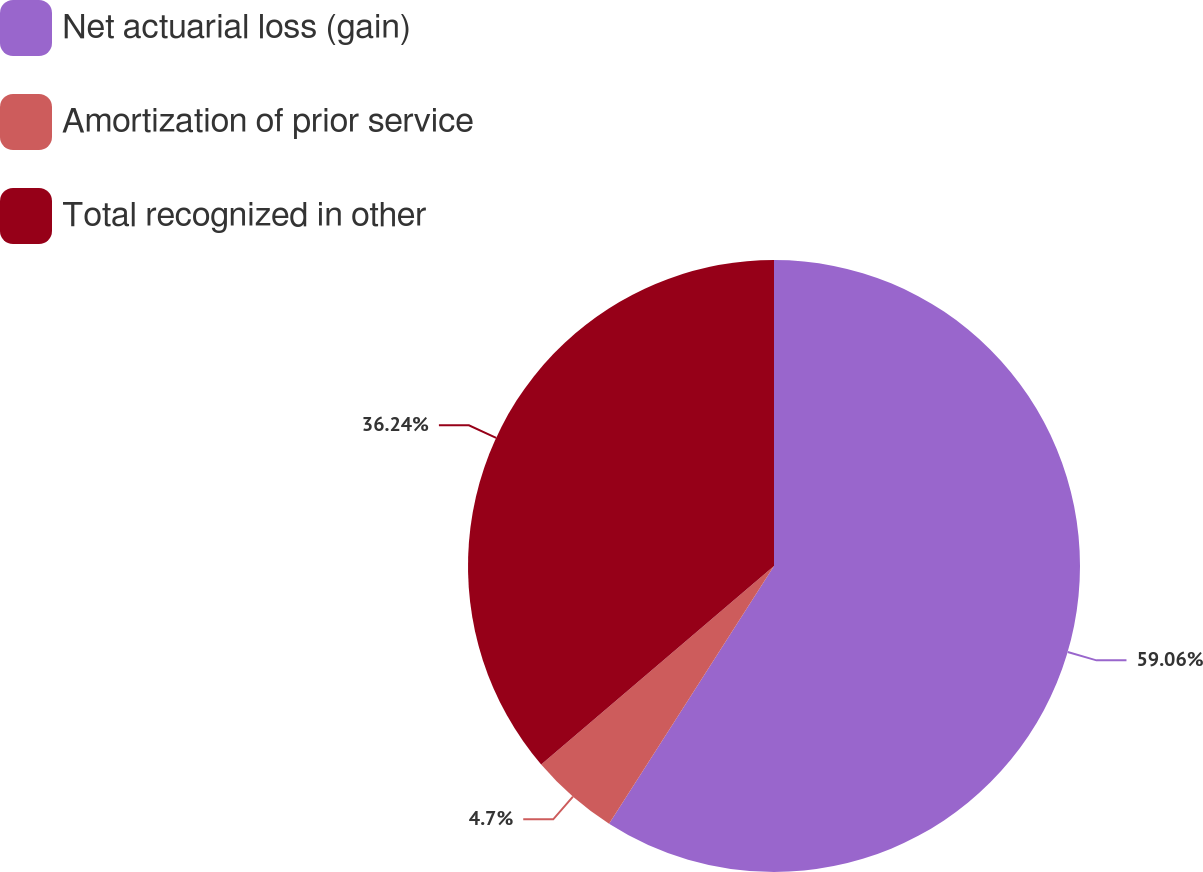Convert chart. <chart><loc_0><loc_0><loc_500><loc_500><pie_chart><fcel>Net actuarial loss (gain)<fcel>Amortization of prior service<fcel>Total recognized in other<nl><fcel>59.06%<fcel>4.7%<fcel>36.24%<nl></chart> 